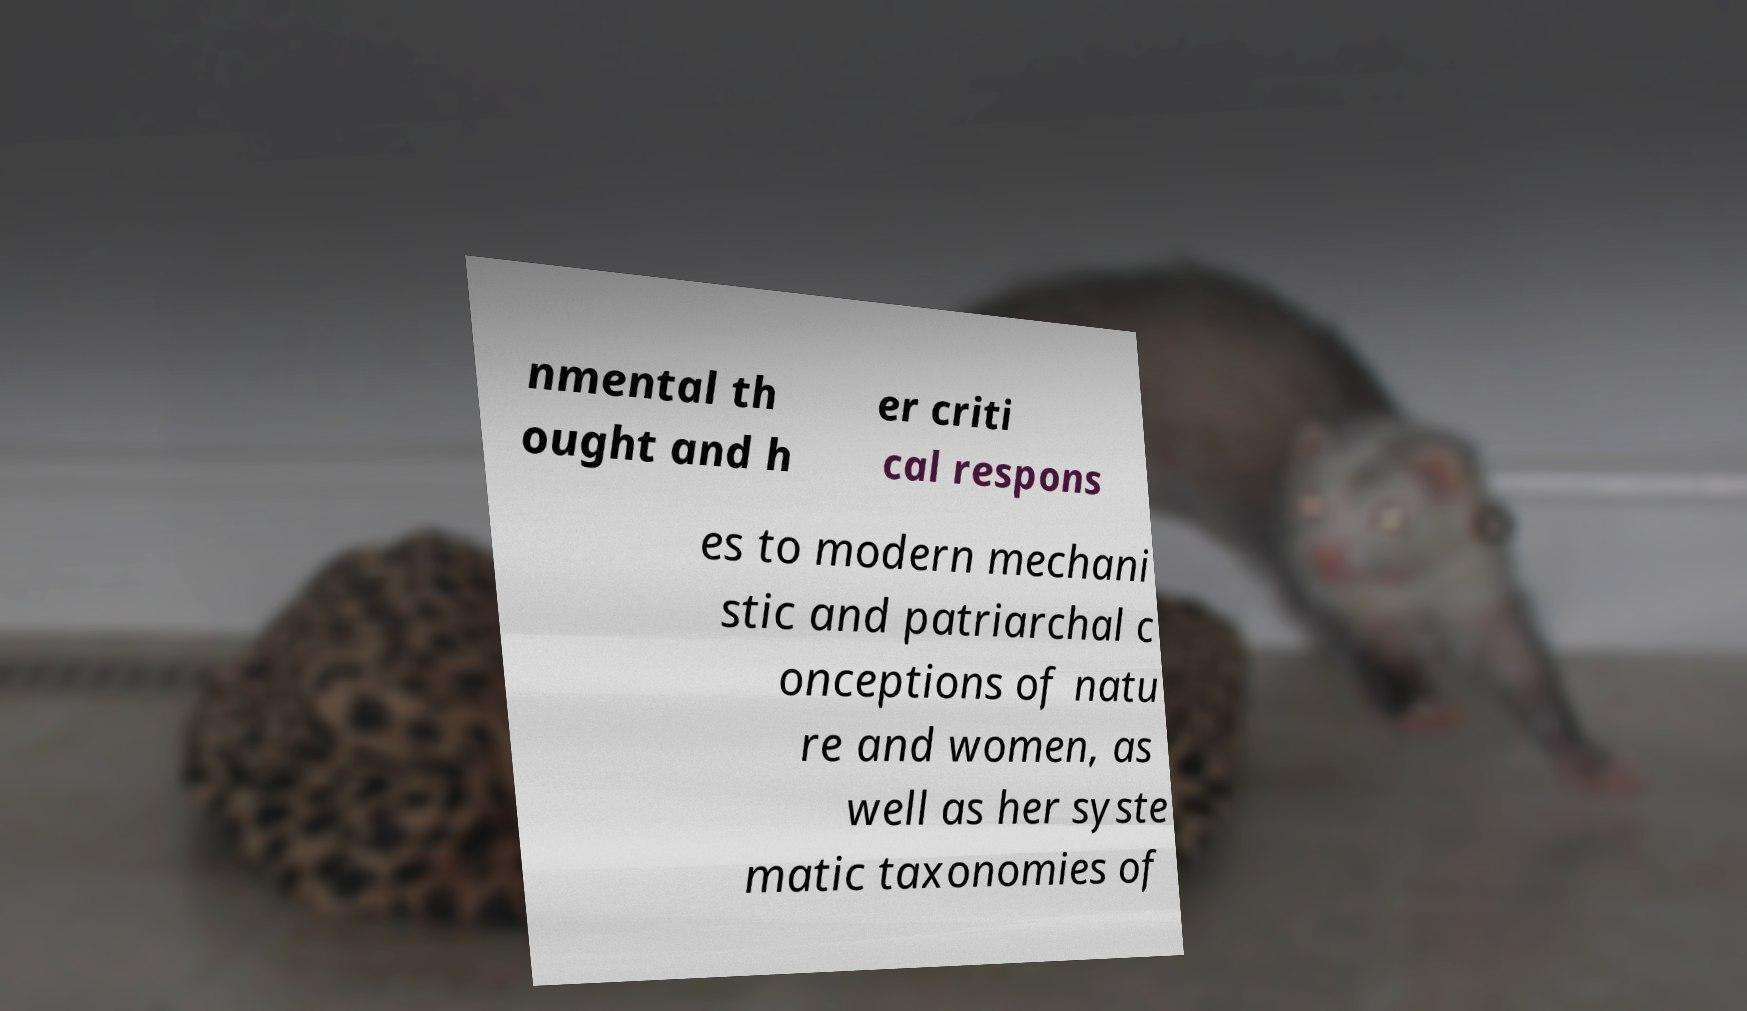Could you assist in decoding the text presented in this image and type it out clearly? nmental th ought and h er criti cal respons es to modern mechani stic and patriarchal c onceptions of natu re and women, as well as her syste matic taxonomies of 